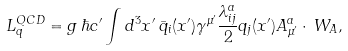Convert formula to latex. <formula><loc_0><loc_0><loc_500><loc_500>L ^ { Q C D } _ { q } = g \, \hbar { c } ^ { \prime } \int d ^ { 3 } x ^ { \prime } \, \bar { q } _ { i } ( x ^ { \prime } ) \gamma ^ { \mu ^ { \prime } } \frac { \lambda _ { i j } ^ { a } } { 2 } q _ { j } ( x ^ { \prime } ) A ^ { a } _ { \mu ^ { \prime } } \cdot \, W _ { A } ,</formula> 